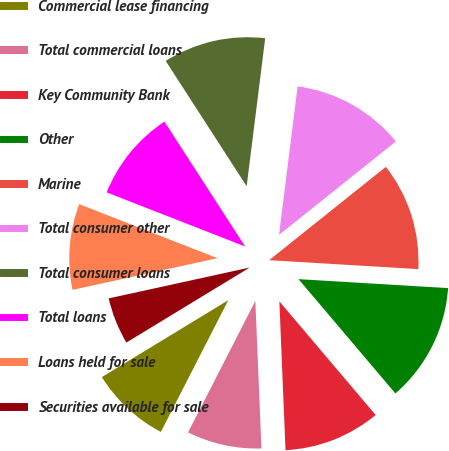Convert chart. <chart><loc_0><loc_0><loc_500><loc_500><pie_chart><fcel>Commercial lease financing<fcel>Total commercial loans<fcel>Key Community Bank<fcel>Other<fcel>Marine<fcel>Total consumer other<fcel>Total consumer loans<fcel>Total loans<fcel>Loans held for sale<fcel>Securities available for sale<nl><fcel>8.77%<fcel>8.19%<fcel>10.53%<fcel>12.86%<fcel>11.69%<fcel>12.28%<fcel>11.11%<fcel>9.94%<fcel>9.36%<fcel>5.27%<nl></chart> 